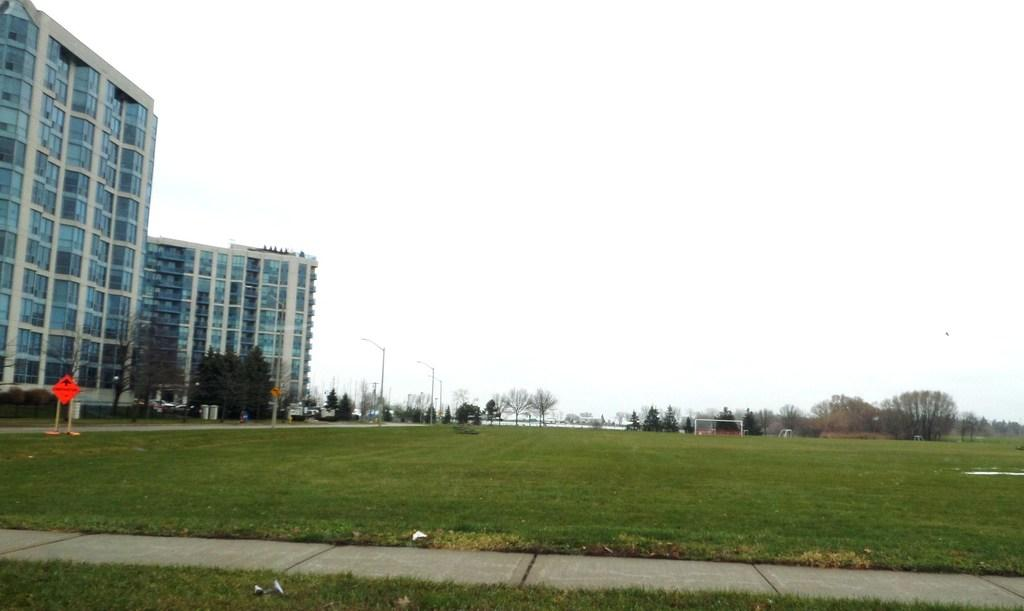What type of surface covers the ground in the image? The ground in the image is covered with grass. What can be seen in the distance in the image? There are trees visible in the background. What type of structures are present in the image? There are buildings in the image. What is present on the road in the image? A hoarding is present on the road. What is the condition of the sky in the image? The sky is clear in the image. Where are the cherries located in the image? There are no cherries present in the image. What type of floor can be seen in the image? The image does not show a floor, as it is an outdoor scene with grass-covered ground. 